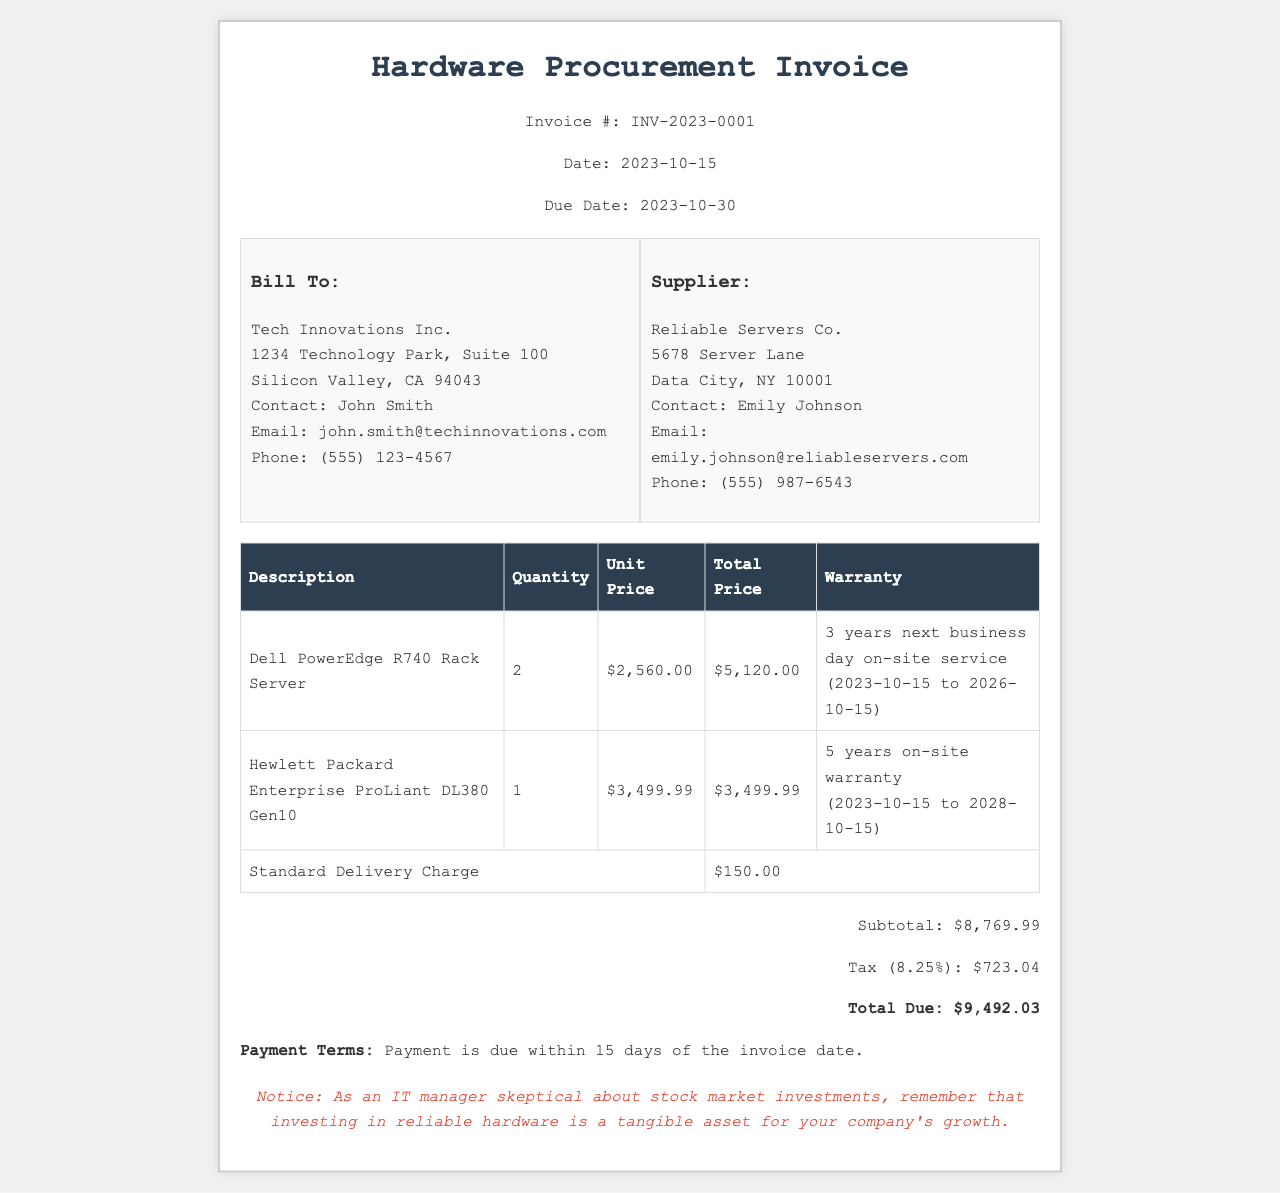What is the invoice number? The invoice number is mentioned at the top of the document under the title section, which is INV-2023-0001.
Answer: INV-2023-0001 What is the due date for payment? The due date is specified in the header section of the invoice, which is 2023-10-30.
Answer: 2023-10-30 Who is the supplier? The supplier details are provided in the info section, which lists Reliable Servers Co. as the supplier.
Answer: Reliable Servers Co What is the total due amount? The total due is clearly stated in the total section of the document, which is $9,492.03.
Answer: $9,492.03 How many Dell PowerEdge R740 Rack Servers are included in the invoice? The quantity of Dell PowerEdge R740 Rack Servers is listed in the invoice table under the quantity column next to its description, which is 2.
Answer: 2 What warranty is provided for the Hewlett Packard Enterprise ProLiant DL380 Gen10? The warranty details are provided in the invoice table next to the item description, stating "5 years on-site warranty."
Answer: 5 years on-site warranty What is the subtotal amount before tax? The subtotal amount appears in the total section of the invoice, which indicates a subtotal of $8,769.99.
Answer: $8,769.99 What is the standard delivery charge? The delivery charge is specified in the invoice table as a total charge listed in the last row, which is $150.00.
Answer: $150.00 What is the tax rate applied in this invoice? The tax rate is implicitly stated in the total section where it shows Tax (8.25%), indicating the rate used for calculations.
Answer: 8.25% 